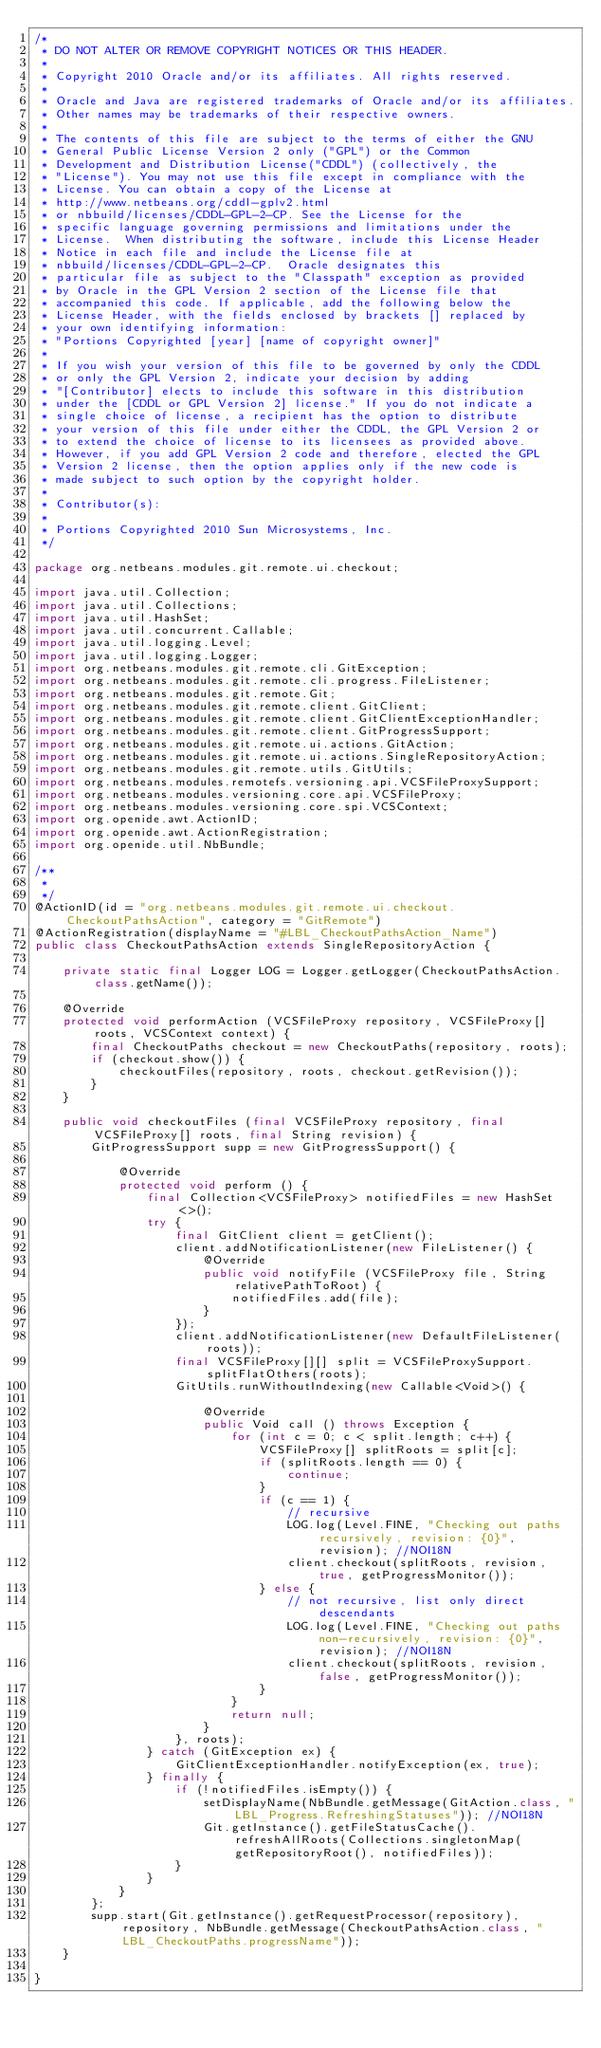Convert code to text. <code><loc_0><loc_0><loc_500><loc_500><_Java_>/*
 * DO NOT ALTER OR REMOVE COPYRIGHT NOTICES OR THIS HEADER.
 *
 * Copyright 2010 Oracle and/or its affiliates. All rights reserved.
 *
 * Oracle and Java are registered trademarks of Oracle and/or its affiliates.
 * Other names may be trademarks of their respective owners.
 *
 * The contents of this file are subject to the terms of either the GNU
 * General Public License Version 2 only ("GPL") or the Common
 * Development and Distribution License("CDDL") (collectively, the
 * "License"). You may not use this file except in compliance with the
 * License. You can obtain a copy of the License at
 * http://www.netbeans.org/cddl-gplv2.html
 * or nbbuild/licenses/CDDL-GPL-2-CP. See the License for the
 * specific language governing permissions and limitations under the
 * License.  When distributing the software, include this License Header
 * Notice in each file and include the License file at
 * nbbuild/licenses/CDDL-GPL-2-CP.  Oracle designates this
 * particular file as subject to the "Classpath" exception as provided
 * by Oracle in the GPL Version 2 section of the License file that
 * accompanied this code. If applicable, add the following below the
 * License Header, with the fields enclosed by brackets [] replaced by
 * your own identifying information:
 * "Portions Copyrighted [year] [name of copyright owner]"
 *
 * If you wish your version of this file to be governed by only the CDDL
 * or only the GPL Version 2, indicate your decision by adding
 * "[Contributor] elects to include this software in this distribution
 * under the [CDDL or GPL Version 2] license." If you do not indicate a
 * single choice of license, a recipient has the option to distribute
 * your version of this file under either the CDDL, the GPL Version 2 or
 * to extend the choice of license to its licensees as provided above.
 * However, if you add GPL Version 2 code and therefore, elected the GPL
 * Version 2 license, then the option applies only if the new code is
 * made subject to such option by the copyright holder.
 *
 * Contributor(s):
 *
 * Portions Copyrighted 2010 Sun Microsystems, Inc.
 */

package org.netbeans.modules.git.remote.ui.checkout;

import java.util.Collection;
import java.util.Collections;
import java.util.HashSet;
import java.util.concurrent.Callable;
import java.util.logging.Level;
import java.util.logging.Logger;
import org.netbeans.modules.git.remote.cli.GitException;
import org.netbeans.modules.git.remote.cli.progress.FileListener;
import org.netbeans.modules.git.remote.Git;
import org.netbeans.modules.git.remote.client.GitClient;
import org.netbeans.modules.git.remote.client.GitClientExceptionHandler;
import org.netbeans.modules.git.remote.client.GitProgressSupport;
import org.netbeans.modules.git.remote.ui.actions.GitAction;
import org.netbeans.modules.git.remote.ui.actions.SingleRepositoryAction;
import org.netbeans.modules.git.remote.utils.GitUtils;
import org.netbeans.modules.remotefs.versioning.api.VCSFileProxySupport;
import org.netbeans.modules.versioning.core.api.VCSFileProxy;
import org.netbeans.modules.versioning.core.spi.VCSContext;
import org.openide.awt.ActionID;
import org.openide.awt.ActionRegistration;
import org.openide.util.NbBundle;

/**
 *
 */
@ActionID(id = "org.netbeans.modules.git.remote.ui.checkout.CheckoutPathsAction", category = "GitRemote")
@ActionRegistration(displayName = "#LBL_CheckoutPathsAction_Name")
public class CheckoutPathsAction extends SingleRepositoryAction {

    private static final Logger LOG = Logger.getLogger(CheckoutPathsAction.class.getName());

    @Override
    protected void performAction (VCSFileProxy repository, VCSFileProxy[] roots, VCSContext context) {
        final CheckoutPaths checkout = new CheckoutPaths(repository, roots);
        if (checkout.show()) {
            checkoutFiles(repository, roots, checkout.getRevision());
        }
    }
    
    public void checkoutFiles (final VCSFileProxy repository, final VCSFileProxy[] roots, final String revision) {
        GitProgressSupport supp = new GitProgressSupport() {

            @Override
            protected void perform () {
                final Collection<VCSFileProxy> notifiedFiles = new HashSet<>();
                try {
                    final GitClient client = getClient();
                    client.addNotificationListener(new FileListener() {
                        @Override
                        public void notifyFile (VCSFileProxy file, String relativePathToRoot) {
                            notifiedFiles.add(file);
                        }
                    });
                    client.addNotificationListener(new DefaultFileListener(roots));
                    final VCSFileProxy[][] split = VCSFileProxySupport.splitFlatOthers(roots);
                    GitUtils.runWithoutIndexing(new Callable<Void>() {

                        @Override
                        public Void call () throws Exception {
                            for (int c = 0; c < split.length; c++) {
                                VCSFileProxy[] splitRoots = split[c];
                                if (splitRoots.length == 0) {
                                    continue;
                                }
                                if (c == 1) {
                                    // recursive
                                    LOG.log(Level.FINE, "Checking out paths recursively, revision: {0}", revision); //NOI18N
                                    client.checkout(splitRoots, revision, true, getProgressMonitor());
                                } else {
                                    // not recursive, list only direct descendants
                                    LOG.log(Level.FINE, "Checking out paths non-recursively, revision: {0}", revision); //NOI18N
                                    client.checkout(splitRoots, revision, false, getProgressMonitor());
                                }
                            }
                            return null;
                        }
                    }, roots);
                } catch (GitException ex) {
                    GitClientExceptionHandler.notifyException(ex, true);
                } finally {
                    if (!notifiedFiles.isEmpty()) {
                        setDisplayName(NbBundle.getMessage(GitAction.class, "LBL_Progress.RefreshingStatuses")); //NOI18N
                        Git.getInstance().getFileStatusCache().refreshAllRoots(Collections.singletonMap(getRepositoryRoot(), notifiedFiles));
                    }
                }
            }
        };
        supp.start(Git.getInstance().getRequestProcessor(repository), repository, NbBundle.getMessage(CheckoutPathsAction.class, "LBL_CheckoutPaths.progressName"));
    }

}
</code> 